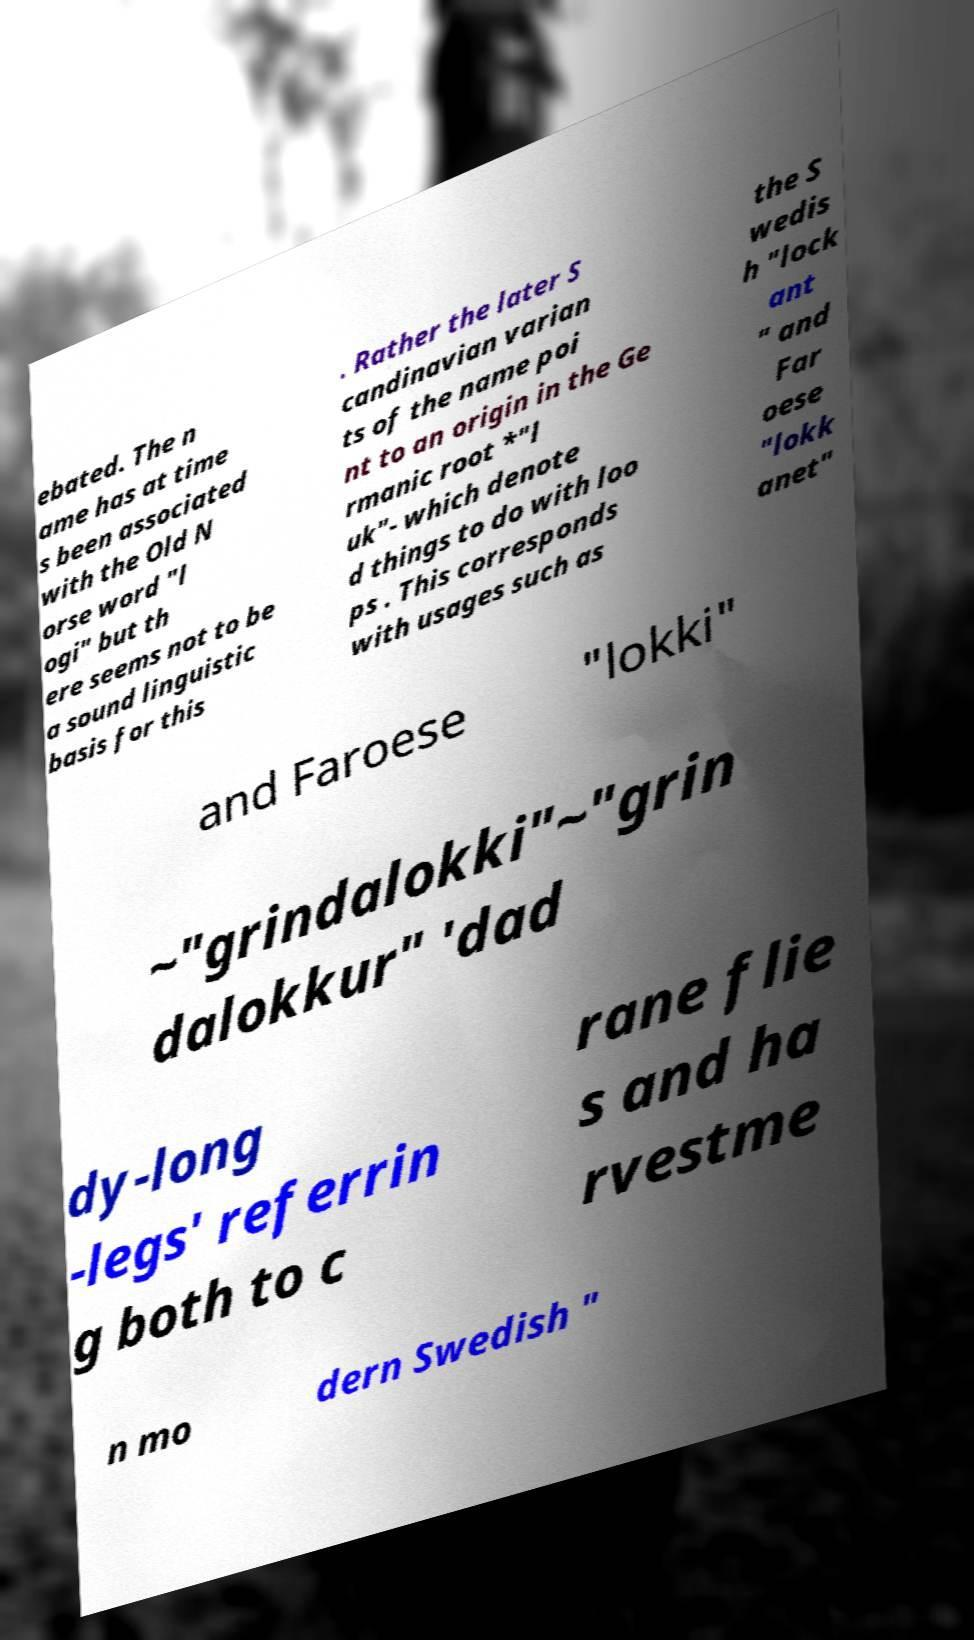Can you accurately transcribe the text from the provided image for me? ebated. The n ame has at time s been associated with the Old N orse word "l ogi" but th ere seems not to be a sound linguistic basis for this . Rather the later S candinavian varian ts of the name poi nt to an origin in the Ge rmanic root *"l uk"- which denote d things to do with loo ps . This corresponds with usages such as the S wedis h "lock ant " and Far oese "lokk anet" and Faroese "lokki" ~"grindalokki"~"grin dalokkur" 'dad dy-long -legs' referrin g both to c rane flie s and ha rvestme n mo dern Swedish " 